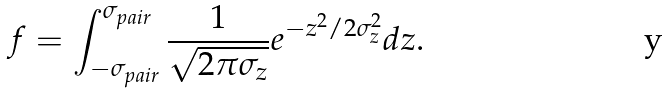<formula> <loc_0><loc_0><loc_500><loc_500>f = \int ^ { \sigma _ { p a i r } } _ { - \sigma _ { p a i r } } \frac { 1 } { \sqrt { 2 \pi \sigma _ { z } } } e ^ { - z ^ { 2 } / 2 \sigma _ { z } ^ { 2 } } d z .</formula> 